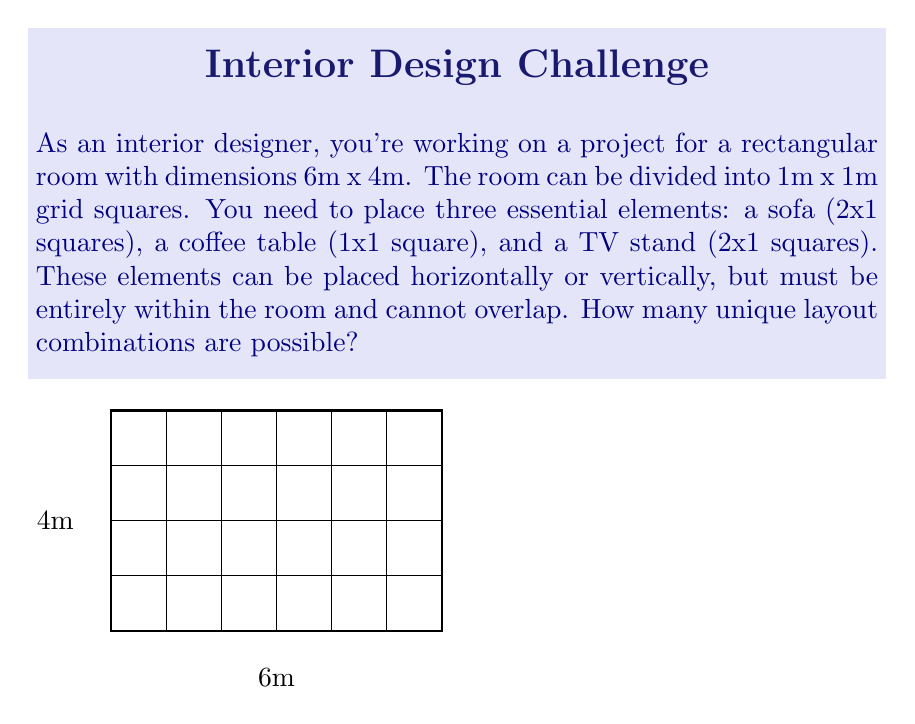Can you solve this math problem? Let's approach this step-by-step:

1) First, let's count the possible positions for each element:

   a) Sofa (2x1):
      - Horizontal: $5 \times 4 = 20$ positions
      - Vertical: $6 \times 3 = 18$ positions
      Total: $20 + 18 = 38$ positions

   b) Coffee table (1x1):
      - $6 \times 4 = 24$ positions

   c) TV stand (2x1):
      - Same as sofa: 38 positions

2) Now, we need to consider all possible combinations. For each position of the sofa, we need to count how many ways we can place the other two elements.

3) Let's use the multiplication principle. For each sofa position:
   - We have 38 choices for the TV stand
   - After placing the sofa and TV stand, we have at most 24 choices for the coffee table (could be less if some squares are occupied)

4) However, this count includes invalid configurations where elements overlap. We need to subtract these:

   - When sofa and TV stand overlap: approximately $\frac{1}{4}$ of combinations
   - When coffee table overlaps with either: approximately $\frac{1}{6}$ of remaining combinations

5) Taking these factors into account, we can estimate the number of valid combinations:

   $$ N \approx 38 \times 38 \times 24 \times (1 - \frac{1}{4}) \times (1 - \frac{1}{6}) $$

6) Calculating:
   $$ N \approx 38 \times 38 \times 24 \times \frac{3}{4} \times \frac{5}{6} = 13,718 $$

This is an approximation due to the simplifications made in estimating overlaps.
Answer: Approximately 13,718 unique layout combinations 